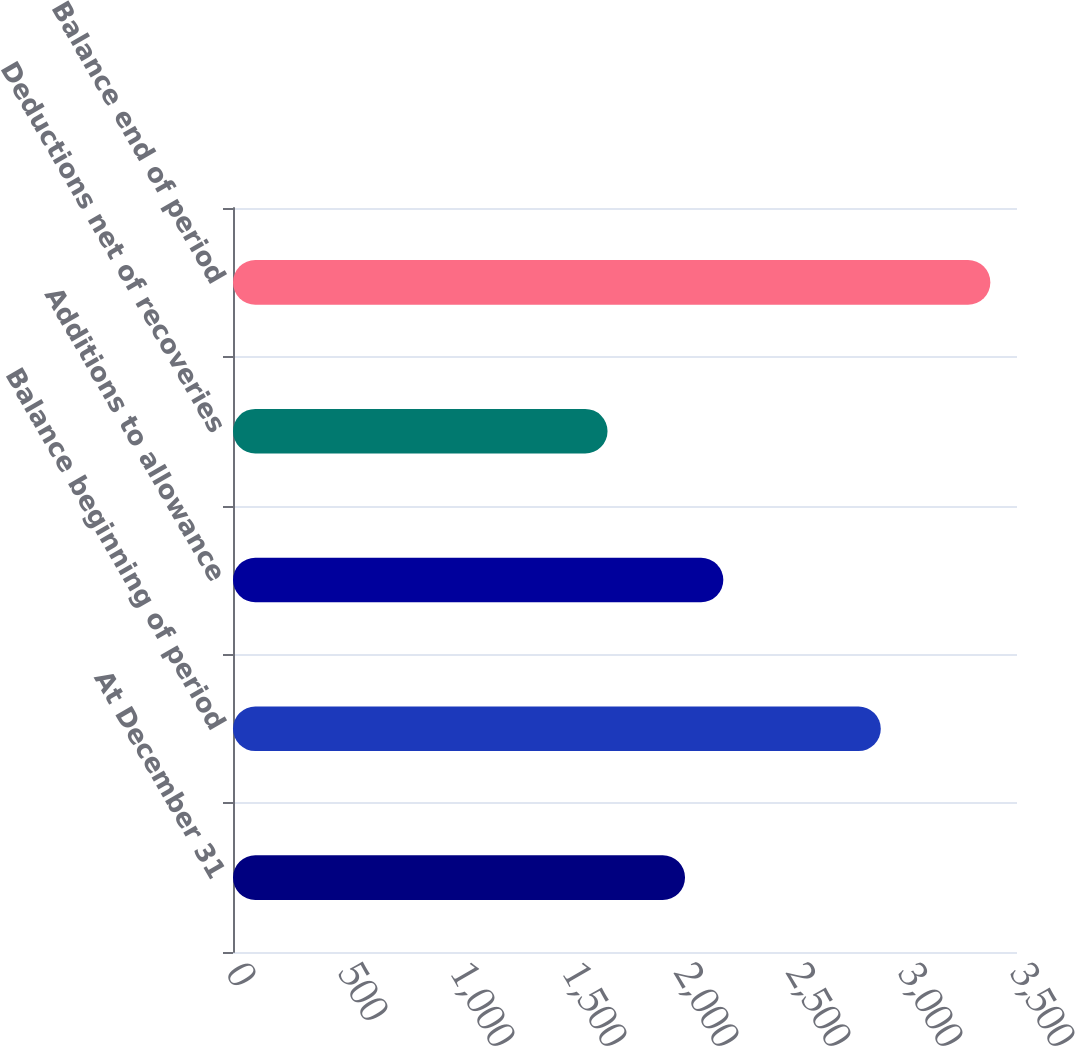Convert chart to OTSL. <chart><loc_0><loc_0><loc_500><loc_500><bar_chart><fcel>At December 31<fcel>Balance beginning of period<fcel>Additions to allowance<fcel>Deductions net of recoveries<fcel>Balance end of period<nl><fcel>2018<fcel>2892<fcel>2188.9<fcel>1672<fcel>3381<nl></chart> 